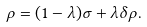<formula> <loc_0><loc_0><loc_500><loc_500>\rho = ( 1 - \lambda ) \sigma + \lambda \delta \rho .</formula> 